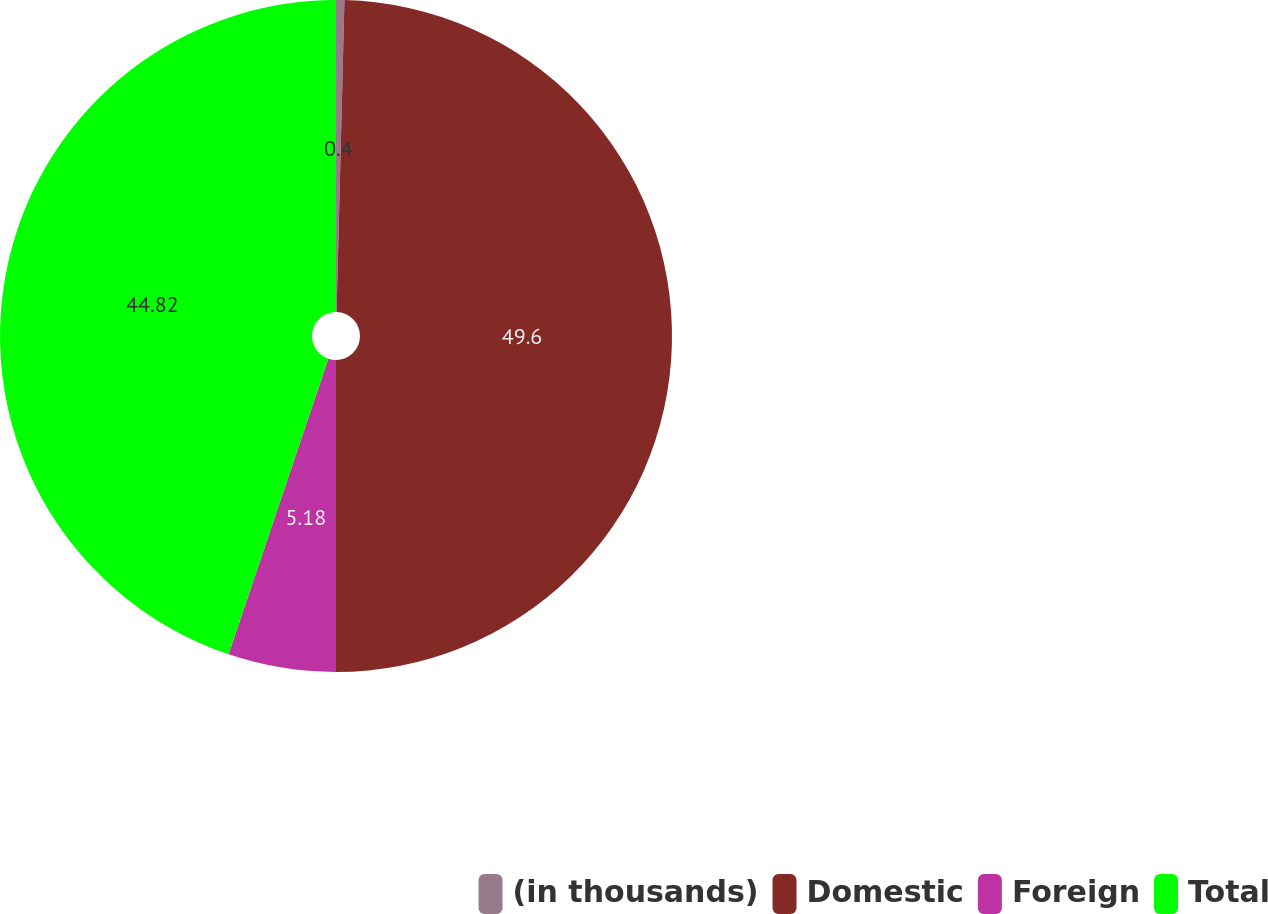Convert chart to OTSL. <chart><loc_0><loc_0><loc_500><loc_500><pie_chart><fcel>(in thousands)<fcel>Domestic<fcel>Foreign<fcel>Total<nl><fcel>0.4%<fcel>49.6%<fcel>5.18%<fcel>44.82%<nl></chart> 